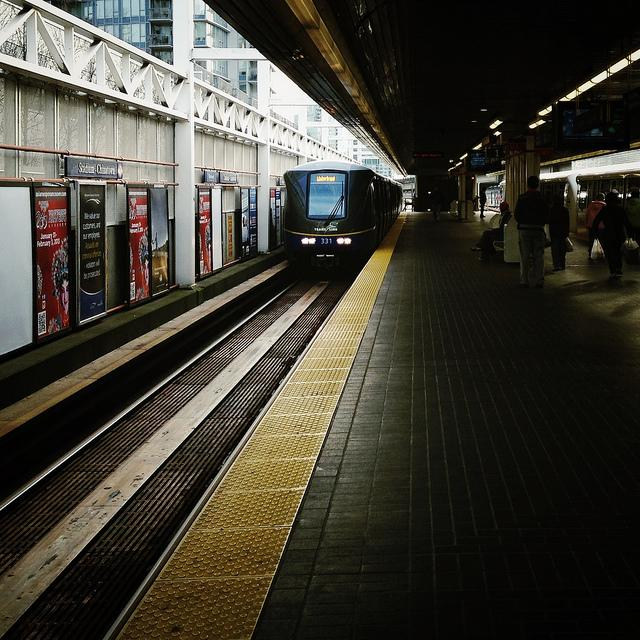What are the colorful posters on the wall used for?

Choices:
A) targets
B) advertising
C) photographing
D) selling advertising 